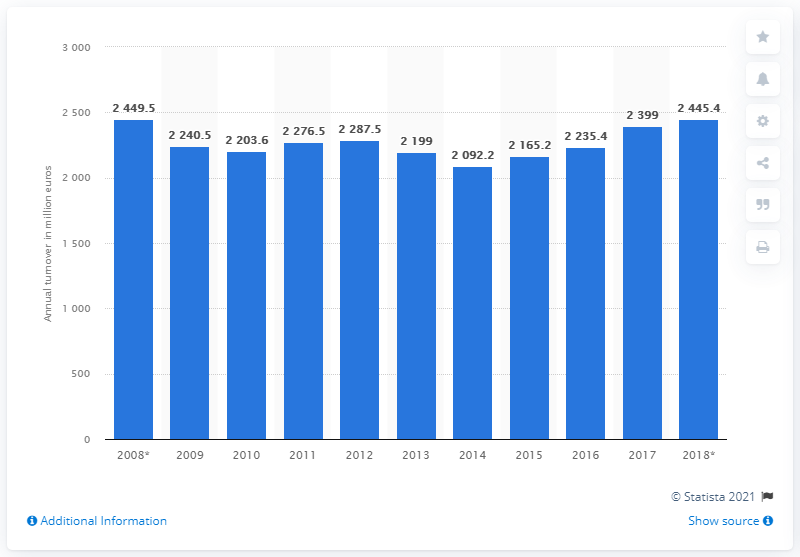Mention a couple of crucial points in this snapshot. In 2018, the production value of processing and production of meat was 2445.4. 